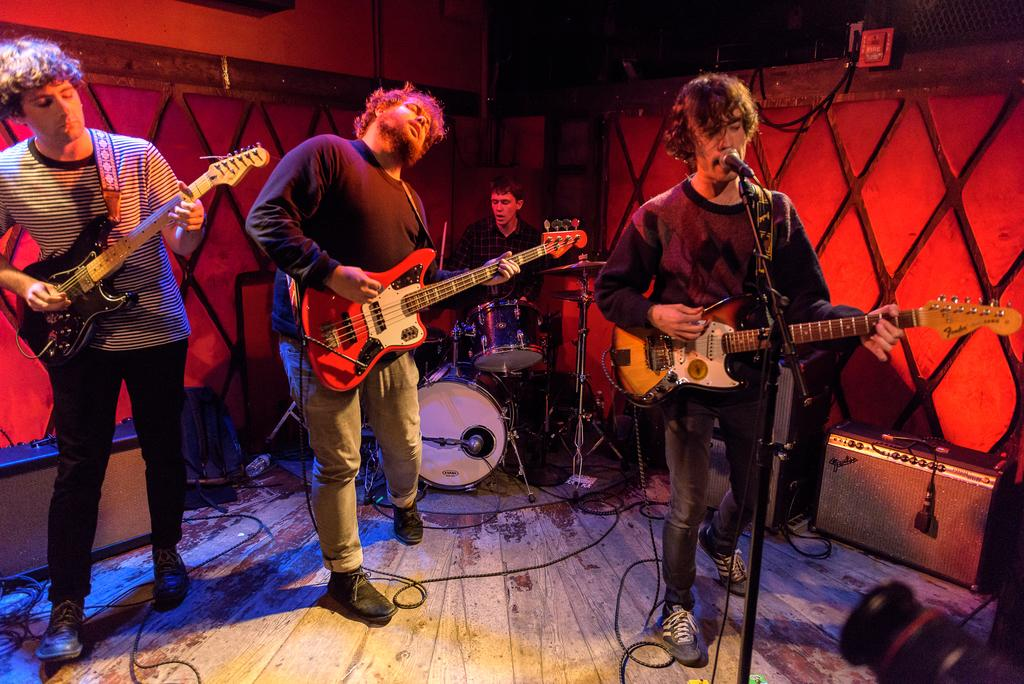How many people are present in the image? There are four people in the image. What are the people doing in the image? The people are playing musical instruments. What type of underwear is visible on the people in the image? There is no underwear visible on the people in the image; they are focused on playing musical instruments. 